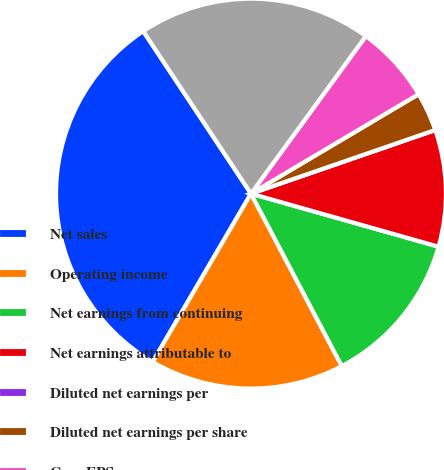Convert chart. <chart><loc_0><loc_0><loc_500><loc_500><pie_chart><fcel>Net sales<fcel>Operating income<fcel>Net earnings from continuing<fcel>Net earnings attributable to<fcel>Diluted net earnings per<fcel>Diluted net earnings per share<fcel>Core EPS<fcel>Cash flow from operating<nl><fcel>32.26%<fcel>16.13%<fcel>12.9%<fcel>9.68%<fcel>0.0%<fcel>3.23%<fcel>6.45%<fcel>19.35%<nl></chart> 